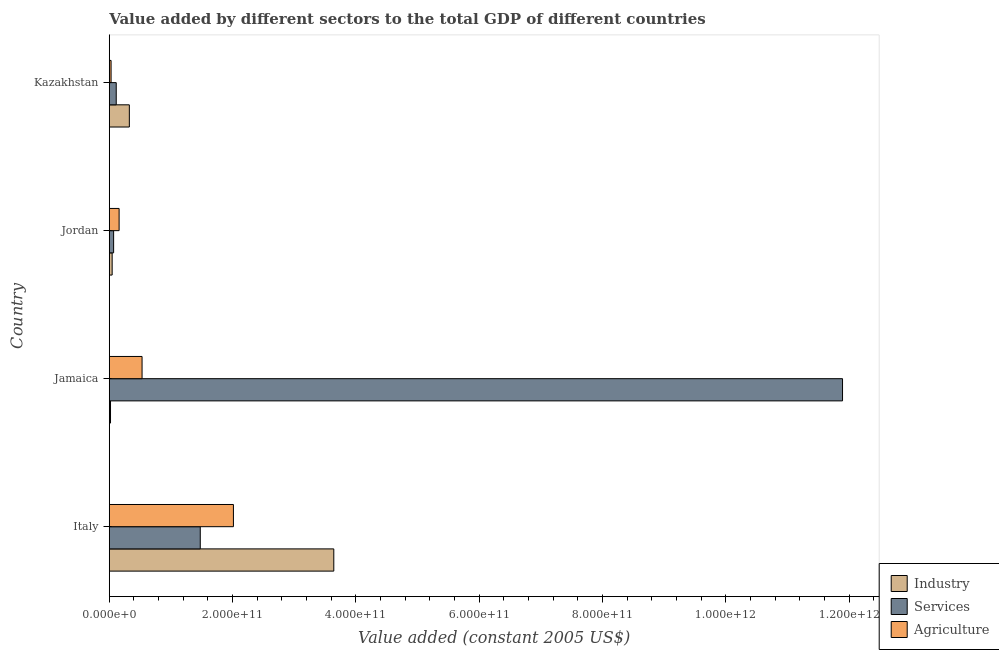Are the number of bars per tick equal to the number of legend labels?
Make the answer very short. Yes. Are the number of bars on each tick of the Y-axis equal?
Your answer should be very brief. Yes. How many bars are there on the 4th tick from the top?
Your response must be concise. 3. What is the label of the 3rd group of bars from the top?
Your response must be concise. Jamaica. In how many cases, is the number of bars for a given country not equal to the number of legend labels?
Provide a succinct answer. 0. What is the value added by services in Jamaica?
Make the answer very short. 1.19e+12. Across all countries, what is the maximum value added by industrial sector?
Provide a short and direct response. 3.64e+11. Across all countries, what is the minimum value added by services?
Your response must be concise. 7.06e+09. In which country was the value added by agricultural sector maximum?
Offer a very short reply. Italy. In which country was the value added by industrial sector minimum?
Give a very brief answer. Jamaica. What is the total value added by agricultural sector in the graph?
Your answer should be compact. 2.73e+11. What is the difference between the value added by industrial sector in Italy and that in Kazakhstan?
Offer a very short reply. 3.32e+11. What is the difference between the value added by industrial sector in Kazakhstan and the value added by agricultural sector in Jordan?
Your response must be concise. 1.66e+1. What is the average value added by industrial sector per country?
Offer a very short reply. 1.01e+11. What is the difference between the value added by industrial sector and value added by services in Kazakhstan?
Your answer should be compact. 2.13e+1. In how many countries, is the value added by agricultural sector greater than 120000000000 US$?
Your response must be concise. 1. What is the ratio of the value added by services in Italy to that in Jamaica?
Give a very brief answer. 0.12. Is the value added by agricultural sector in Italy less than that in Jordan?
Keep it short and to the point. No. Is the difference between the value added by industrial sector in Italy and Kazakhstan greater than the difference between the value added by services in Italy and Kazakhstan?
Keep it short and to the point. Yes. What is the difference between the highest and the second highest value added by agricultural sector?
Make the answer very short. 1.48e+11. What is the difference between the highest and the lowest value added by industrial sector?
Give a very brief answer. 3.62e+11. In how many countries, is the value added by industrial sector greater than the average value added by industrial sector taken over all countries?
Your response must be concise. 1. Is the sum of the value added by agricultural sector in Jamaica and Kazakhstan greater than the maximum value added by industrial sector across all countries?
Make the answer very short. No. What does the 3rd bar from the top in Jamaica represents?
Keep it short and to the point. Industry. What does the 2nd bar from the bottom in Kazakhstan represents?
Your answer should be compact. Services. Is it the case that in every country, the sum of the value added by industrial sector and value added by services is greater than the value added by agricultural sector?
Offer a very short reply. No. What is the difference between two consecutive major ticks on the X-axis?
Offer a terse response. 2.00e+11. Are the values on the major ticks of X-axis written in scientific E-notation?
Provide a succinct answer. Yes. Does the graph contain grids?
Ensure brevity in your answer.  No. How are the legend labels stacked?
Ensure brevity in your answer.  Vertical. What is the title of the graph?
Your answer should be very brief. Value added by different sectors to the total GDP of different countries. What is the label or title of the X-axis?
Ensure brevity in your answer.  Value added (constant 2005 US$). What is the Value added (constant 2005 US$) in Industry in Italy?
Make the answer very short. 3.64e+11. What is the Value added (constant 2005 US$) of Services in Italy?
Your response must be concise. 1.48e+11. What is the Value added (constant 2005 US$) of Agriculture in Italy?
Your response must be concise. 2.01e+11. What is the Value added (constant 2005 US$) of Industry in Jamaica?
Provide a short and direct response. 2.01e+09. What is the Value added (constant 2005 US$) of Services in Jamaica?
Provide a succinct answer. 1.19e+12. What is the Value added (constant 2005 US$) in Agriculture in Jamaica?
Your answer should be compact. 5.32e+1. What is the Value added (constant 2005 US$) in Industry in Jordan?
Give a very brief answer. 4.67e+09. What is the Value added (constant 2005 US$) in Services in Jordan?
Your answer should be very brief. 7.06e+09. What is the Value added (constant 2005 US$) in Agriculture in Jordan?
Offer a terse response. 1.59e+1. What is the Value added (constant 2005 US$) of Industry in Kazakhstan?
Keep it short and to the point. 3.26e+1. What is the Value added (constant 2005 US$) in Services in Kazakhstan?
Provide a short and direct response. 1.13e+1. What is the Value added (constant 2005 US$) of Agriculture in Kazakhstan?
Your answer should be compact. 2.92e+09. Across all countries, what is the maximum Value added (constant 2005 US$) in Industry?
Give a very brief answer. 3.64e+11. Across all countries, what is the maximum Value added (constant 2005 US$) of Services?
Give a very brief answer. 1.19e+12. Across all countries, what is the maximum Value added (constant 2005 US$) in Agriculture?
Ensure brevity in your answer.  2.01e+11. Across all countries, what is the minimum Value added (constant 2005 US$) in Industry?
Your answer should be compact. 2.01e+09. Across all countries, what is the minimum Value added (constant 2005 US$) in Services?
Your answer should be compact. 7.06e+09. Across all countries, what is the minimum Value added (constant 2005 US$) in Agriculture?
Provide a succinct answer. 2.92e+09. What is the total Value added (constant 2005 US$) in Industry in the graph?
Your answer should be compact. 4.03e+11. What is the total Value added (constant 2005 US$) of Services in the graph?
Your response must be concise. 1.36e+12. What is the total Value added (constant 2005 US$) in Agriculture in the graph?
Give a very brief answer. 2.73e+11. What is the difference between the Value added (constant 2005 US$) in Industry in Italy and that in Jamaica?
Keep it short and to the point. 3.62e+11. What is the difference between the Value added (constant 2005 US$) in Services in Italy and that in Jamaica?
Offer a very short reply. -1.04e+12. What is the difference between the Value added (constant 2005 US$) in Agriculture in Italy and that in Jamaica?
Ensure brevity in your answer.  1.48e+11. What is the difference between the Value added (constant 2005 US$) of Industry in Italy and that in Jordan?
Offer a terse response. 3.59e+11. What is the difference between the Value added (constant 2005 US$) in Services in Italy and that in Jordan?
Give a very brief answer. 1.41e+11. What is the difference between the Value added (constant 2005 US$) of Agriculture in Italy and that in Jordan?
Ensure brevity in your answer.  1.85e+11. What is the difference between the Value added (constant 2005 US$) of Industry in Italy and that in Kazakhstan?
Offer a terse response. 3.32e+11. What is the difference between the Value added (constant 2005 US$) in Services in Italy and that in Kazakhstan?
Make the answer very short. 1.36e+11. What is the difference between the Value added (constant 2005 US$) in Agriculture in Italy and that in Kazakhstan?
Keep it short and to the point. 1.98e+11. What is the difference between the Value added (constant 2005 US$) of Industry in Jamaica and that in Jordan?
Your response must be concise. -2.66e+09. What is the difference between the Value added (constant 2005 US$) in Services in Jamaica and that in Jordan?
Your answer should be very brief. 1.18e+12. What is the difference between the Value added (constant 2005 US$) of Agriculture in Jamaica and that in Jordan?
Keep it short and to the point. 3.72e+1. What is the difference between the Value added (constant 2005 US$) of Industry in Jamaica and that in Kazakhstan?
Ensure brevity in your answer.  -3.05e+1. What is the difference between the Value added (constant 2005 US$) of Services in Jamaica and that in Kazakhstan?
Provide a succinct answer. 1.18e+12. What is the difference between the Value added (constant 2005 US$) in Agriculture in Jamaica and that in Kazakhstan?
Offer a terse response. 5.03e+1. What is the difference between the Value added (constant 2005 US$) in Industry in Jordan and that in Kazakhstan?
Your response must be concise. -2.79e+1. What is the difference between the Value added (constant 2005 US$) of Services in Jordan and that in Kazakhstan?
Your response must be concise. -4.24e+09. What is the difference between the Value added (constant 2005 US$) of Agriculture in Jordan and that in Kazakhstan?
Provide a short and direct response. 1.30e+1. What is the difference between the Value added (constant 2005 US$) in Industry in Italy and the Value added (constant 2005 US$) in Services in Jamaica?
Offer a terse response. -8.25e+11. What is the difference between the Value added (constant 2005 US$) of Industry in Italy and the Value added (constant 2005 US$) of Agriculture in Jamaica?
Provide a succinct answer. 3.11e+11. What is the difference between the Value added (constant 2005 US$) of Services in Italy and the Value added (constant 2005 US$) of Agriculture in Jamaica?
Give a very brief answer. 9.44e+1. What is the difference between the Value added (constant 2005 US$) in Industry in Italy and the Value added (constant 2005 US$) in Services in Jordan?
Your answer should be compact. 3.57e+11. What is the difference between the Value added (constant 2005 US$) of Industry in Italy and the Value added (constant 2005 US$) of Agriculture in Jordan?
Ensure brevity in your answer.  3.48e+11. What is the difference between the Value added (constant 2005 US$) of Services in Italy and the Value added (constant 2005 US$) of Agriculture in Jordan?
Your answer should be very brief. 1.32e+11. What is the difference between the Value added (constant 2005 US$) of Industry in Italy and the Value added (constant 2005 US$) of Services in Kazakhstan?
Provide a succinct answer. 3.53e+11. What is the difference between the Value added (constant 2005 US$) of Industry in Italy and the Value added (constant 2005 US$) of Agriculture in Kazakhstan?
Your answer should be compact. 3.61e+11. What is the difference between the Value added (constant 2005 US$) in Services in Italy and the Value added (constant 2005 US$) in Agriculture in Kazakhstan?
Offer a terse response. 1.45e+11. What is the difference between the Value added (constant 2005 US$) of Industry in Jamaica and the Value added (constant 2005 US$) of Services in Jordan?
Make the answer very short. -5.05e+09. What is the difference between the Value added (constant 2005 US$) of Industry in Jamaica and the Value added (constant 2005 US$) of Agriculture in Jordan?
Keep it short and to the point. -1.39e+1. What is the difference between the Value added (constant 2005 US$) in Services in Jamaica and the Value added (constant 2005 US$) in Agriculture in Jordan?
Offer a terse response. 1.17e+12. What is the difference between the Value added (constant 2005 US$) in Industry in Jamaica and the Value added (constant 2005 US$) in Services in Kazakhstan?
Your answer should be compact. -9.28e+09. What is the difference between the Value added (constant 2005 US$) in Industry in Jamaica and the Value added (constant 2005 US$) in Agriculture in Kazakhstan?
Make the answer very short. -9.03e+08. What is the difference between the Value added (constant 2005 US$) in Services in Jamaica and the Value added (constant 2005 US$) in Agriculture in Kazakhstan?
Offer a terse response. 1.19e+12. What is the difference between the Value added (constant 2005 US$) in Industry in Jordan and the Value added (constant 2005 US$) in Services in Kazakhstan?
Keep it short and to the point. -6.62e+09. What is the difference between the Value added (constant 2005 US$) of Industry in Jordan and the Value added (constant 2005 US$) of Agriculture in Kazakhstan?
Provide a short and direct response. 1.76e+09. What is the difference between the Value added (constant 2005 US$) in Services in Jordan and the Value added (constant 2005 US$) in Agriculture in Kazakhstan?
Keep it short and to the point. 4.14e+09. What is the average Value added (constant 2005 US$) of Industry per country?
Offer a very short reply. 1.01e+11. What is the average Value added (constant 2005 US$) in Services per country?
Your answer should be compact. 3.39e+11. What is the average Value added (constant 2005 US$) of Agriculture per country?
Your answer should be compact. 6.83e+1. What is the difference between the Value added (constant 2005 US$) in Industry and Value added (constant 2005 US$) in Services in Italy?
Your response must be concise. 2.17e+11. What is the difference between the Value added (constant 2005 US$) in Industry and Value added (constant 2005 US$) in Agriculture in Italy?
Ensure brevity in your answer.  1.63e+11. What is the difference between the Value added (constant 2005 US$) of Services and Value added (constant 2005 US$) of Agriculture in Italy?
Give a very brief answer. -5.38e+1. What is the difference between the Value added (constant 2005 US$) of Industry and Value added (constant 2005 US$) of Services in Jamaica?
Keep it short and to the point. -1.19e+12. What is the difference between the Value added (constant 2005 US$) in Industry and Value added (constant 2005 US$) in Agriculture in Jamaica?
Your response must be concise. -5.12e+1. What is the difference between the Value added (constant 2005 US$) in Services and Value added (constant 2005 US$) in Agriculture in Jamaica?
Provide a short and direct response. 1.14e+12. What is the difference between the Value added (constant 2005 US$) in Industry and Value added (constant 2005 US$) in Services in Jordan?
Your answer should be very brief. -2.39e+09. What is the difference between the Value added (constant 2005 US$) of Industry and Value added (constant 2005 US$) of Agriculture in Jordan?
Provide a short and direct response. -1.13e+1. What is the difference between the Value added (constant 2005 US$) in Services and Value added (constant 2005 US$) in Agriculture in Jordan?
Give a very brief answer. -8.88e+09. What is the difference between the Value added (constant 2005 US$) of Industry and Value added (constant 2005 US$) of Services in Kazakhstan?
Provide a short and direct response. 2.13e+1. What is the difference between the Value added (constant 2005 US$) in Industry and Value added (constant 2005 US$) in Agriculture in Kazakhstan?
Provide a short and direct response. 2.96e+1. What is the difference between the Value added (constant 2005 US$) of Services and Value added (constant 2005 US$) of Agriculture in Kazakhstan?
Ensure brevity in your answer.  8.38e+09. What is the ratio of the Value added (constant 2005 US$) of Industry in Italy to that in Jamaica?
Your answer should be compact. 180.83. What is the ratio of the Value added (constant 2005 US$) in Services in Italy to that in Jamaica?
Offer a terse response. 0.12. What is the ratio of the Value added (constant 2005 US$) in Agriculture in Italy to that in Jamaica?
Your answer should be compact. 3.79. What is the ratio of the Value added (constant 2005 US$) in Industry in Italy to that in Jordan?
Your answer should be compact. 77.94. What is the ratio of the Value added (constant 2005 US$) in Services in Italy to that in Jordan?
Your response must be concise. 20.9. What is the ratio of the Value added (constant 2005 US$) in Agriculture in Italy to that in Jordan?
Offer a terse response. 12.63. What is the ratio of the Value added (constant 2005 US$) in Industry in Italy to that in Kazakhstan?
Provide a short and direct response. 11.19. What is the ratio of the Value added (constant 2005 US$) in Services in Italy to that in Kazakhstan?
Your response must be concise. 13.06. What is the ratio of the Value added (constant 2005 US$) in Agriculture in Italy to that in Kazakhstan?
Provide a succinct answer. 69.03. What is the ratio of the Value added (constant 2005 US$) of Industry in Jamaica to that in Jordan?
Your response must be concise. 0.43. What is the ratio of the Value added (constant 2005 US$) in Services in Jamaica to that in Jordan?
Give a very brief answer. 168.44. What is the ratio of the Value added (constant 2005 US$) in Agriculture in Jamaica to that in Jordan?
Provide a short and direct response. 3.33. What is the ratio of the Value added (constant 2005 US$) of Industry in Jamaica to that in Kazakhstan?
Offer a terse response. 0.06. What is the ratio of the Value added (constant 2005 US$) in Services in Jamaica to that in Kazakhstan?
Provide a succinct answer. 105.26. What is the ratio of the Value added (constant 2005 US$) of Agriculture in Jamaica to that in Kazakhstan?
Give a very brief answer. 18.23. What is the ratio of the Value added (constant 2005 US$) in Industry in Jordan to that in Kazakhstan?
Provide a short and direct response. 0.14. What is the ratio of the Value added (constant 2005 US$) of Services in Jordan to that in Kazakhstan?
Your answer should be compact. 0.62. What is the ratio of the Value added (constant 2005 US$) of Agriculture in Jordan to that in Kazakhstan?
Ensure brevity in your answer.  5.47. What is the difference between the highest and the second highest Value added (constant 2005 US$) of Industry?
Ensure brevity in your answer.  3.32e+11. What is the difference between the highest and the second highest Value added (constant 2005 US$) of Services?
Ensure brevity in your answer.  1.04e+12. What is the difference between the highest and the second highest Value added (constant 2005 US$) of Agriculture?
Your response must be concise. 1.48e+11. What is the difference between the highest and the lowest Value added (constant 2005 US$) of Industry?
Ensure brevity in your answer.  3.62e+11. What is the difference between the highest and the lowest Value added (constant 2005 US$) of Services?
Keep it short and to the point. 1.18e+12. What is the difference between the highest and the lowest Value added (constant 2005 US$) of Agriculture?
Make the answer very short. 1.98e+11. 